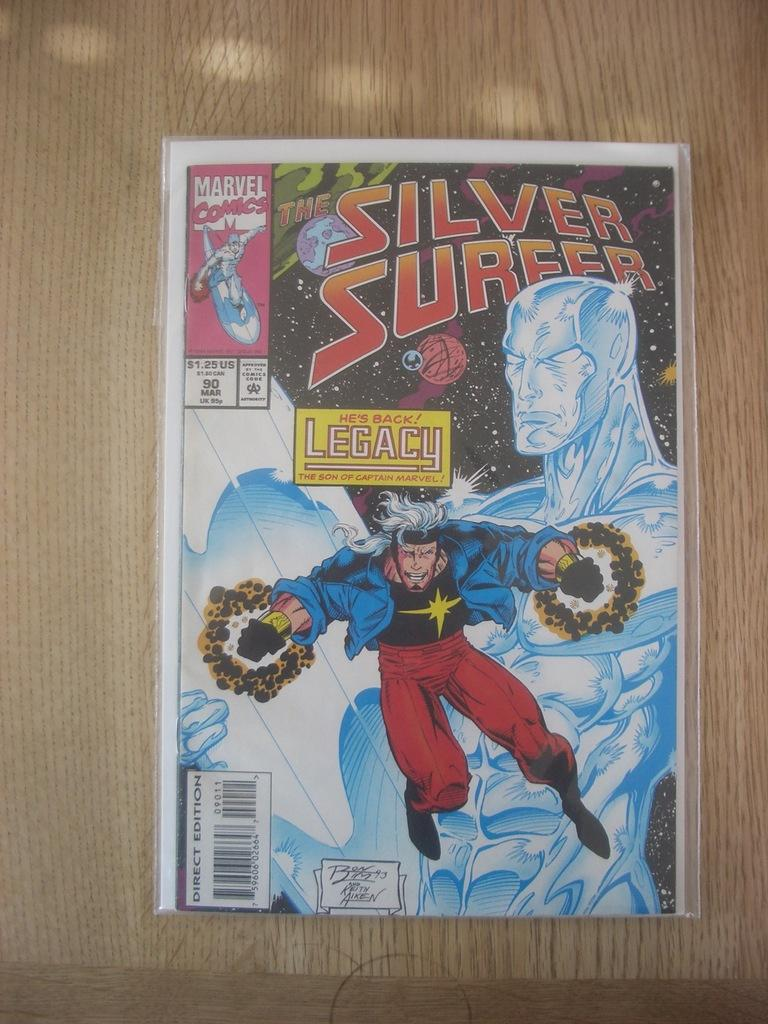Provide a one-sentence caption for the provided image. A silver surfer comic in a plastic covering with, "He's back! Legacy," printed above a fling male. 